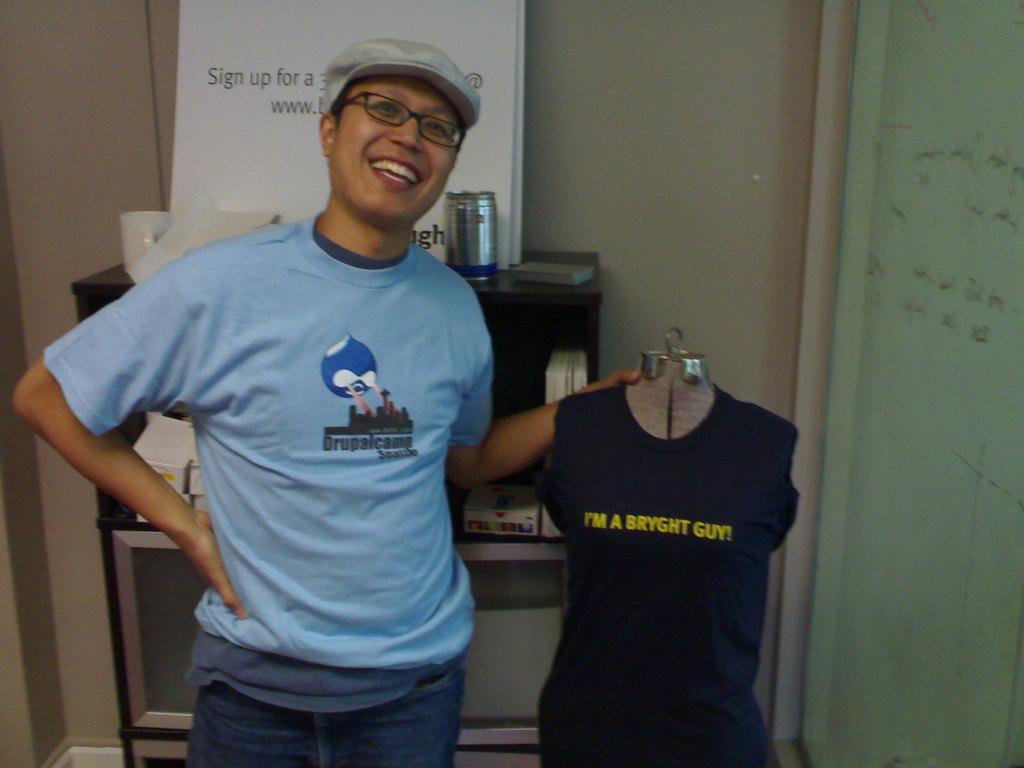Please provide a concise description of this image. In the picture we can see a man standing on the floor and he is with blue T-shirt and smiling and he is holding a hanger with black T-shirt to it and written on it as I am a bright guy and in the background, we can see a wall and a rack on the top of it, we can see a steel jar and a white color board with some information on it and inside the wall we can see another wall which is light green in color with some information on it. 